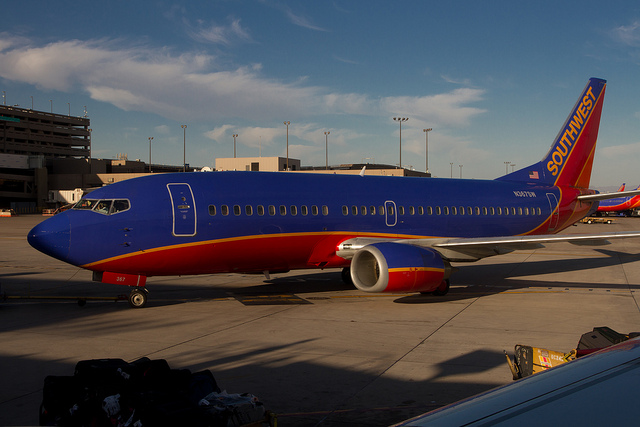Please transcribe the text in this image. SOUTHWEST 